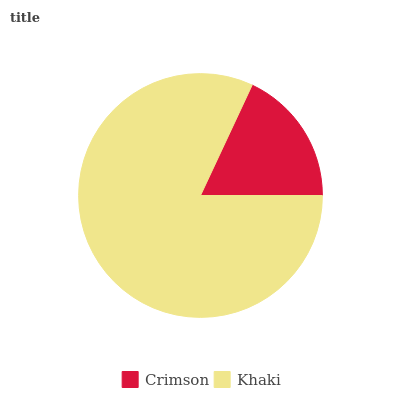Is Crimson the minimum?
Answer yes or no. Yes. Is Khaki the maximum?
Answer yes or no. Yes. Is Khaki the minimum?
Answer yes or no. No. Is Khaki greater than Crimson?
Answer yes or no. Yes. Is Crimson less than Khaki?
Answer yes or no. Yes. Is Crimson greater than Khaki?
Answer yes or no. No. Is Khaki less than Crimson?
Answer yes or no. No. Is Khaki the high median?
Answer yes or no. Yes. Is Crimson the low median?
Answer yes or no. Yes. Is Crimson the high median?
Answer yes or no. No. Is Khaki the low median?
Answer yes or no. No. 